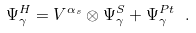<formula> <loc_0><loc_0><loc_500><loc_500>\Psi _ { \gamma } ^ { H } = V ^ { \alpha _ { s } } \otimes \Psi _ { \gamma } ^ { S } + \Psi _ { \gamma } ^ { P t } \ .</formula> 